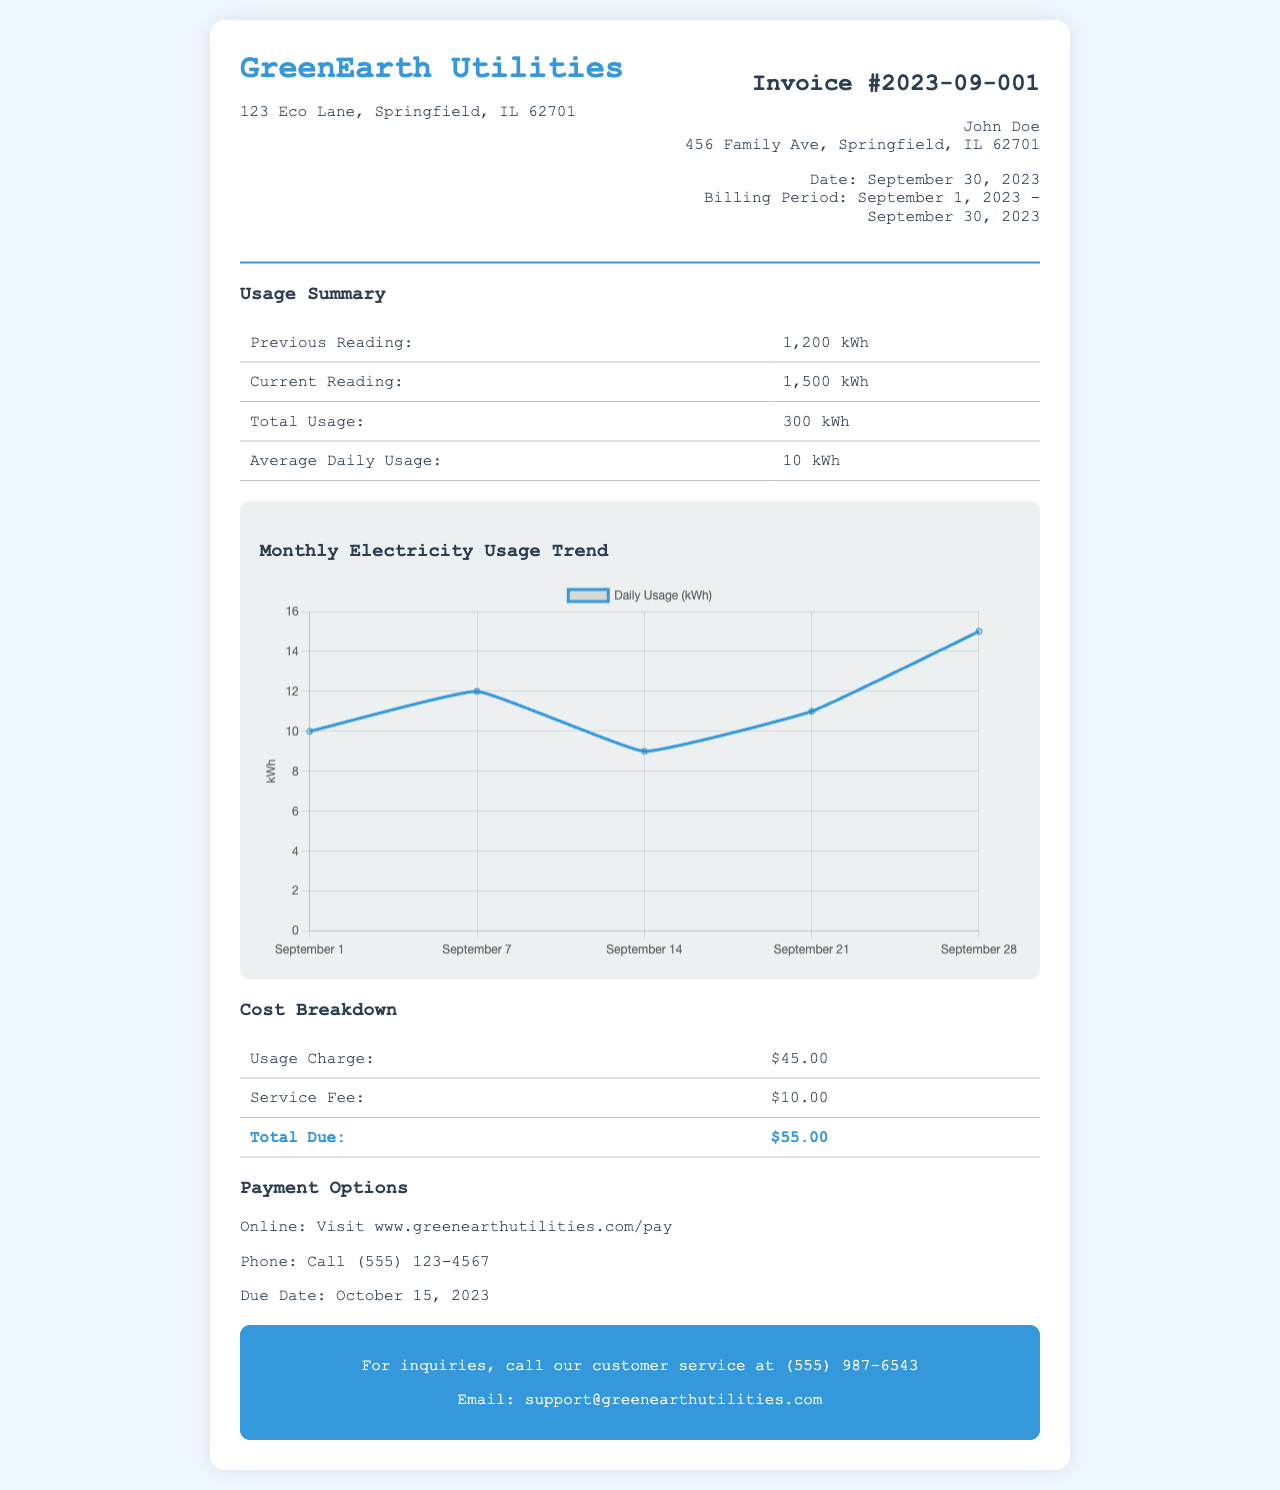what is the invoice number? The invoice number is stated in the document header as the unique identifier for the billing period.
Answer: 2023-09-001 what is the total usage in kWh for September? The total usage is provided in the usage summary section, calculated as the difference between current and previous readings.
Answer: 300 kWh what is the total amount due? The total amount due is specified in the cost breakdown section, representing the sum of the usage charge and service fee.
Answer: $55.00 when is the due date for payment? The due date for payment is clearly mentioned in the payment options section of the document.
Answer: October 15, 2023 what is the average daily usage in kWh? The average daily usage is presented in the usage summary and is calculated by dividing total usage by the number of days in the billing period.
Answer: 10 kWh which payment method is available? The payment options section lists the methods available for settling the invoice.
Answer: Online, Phone how many days are in the billing period? The billing period is defined in the document and is the time frame between the previous and the current readings.
Answer: 30 days what was the previous reading? The previous reading is important for calculating the total usage and is found in the usage summary section.
Answer: 1,200 kWh who should be contacted for inquiries? The document provides contact information for customer service, which is important for addressing any questions or concerns.
Answer: (555) 987-6543 